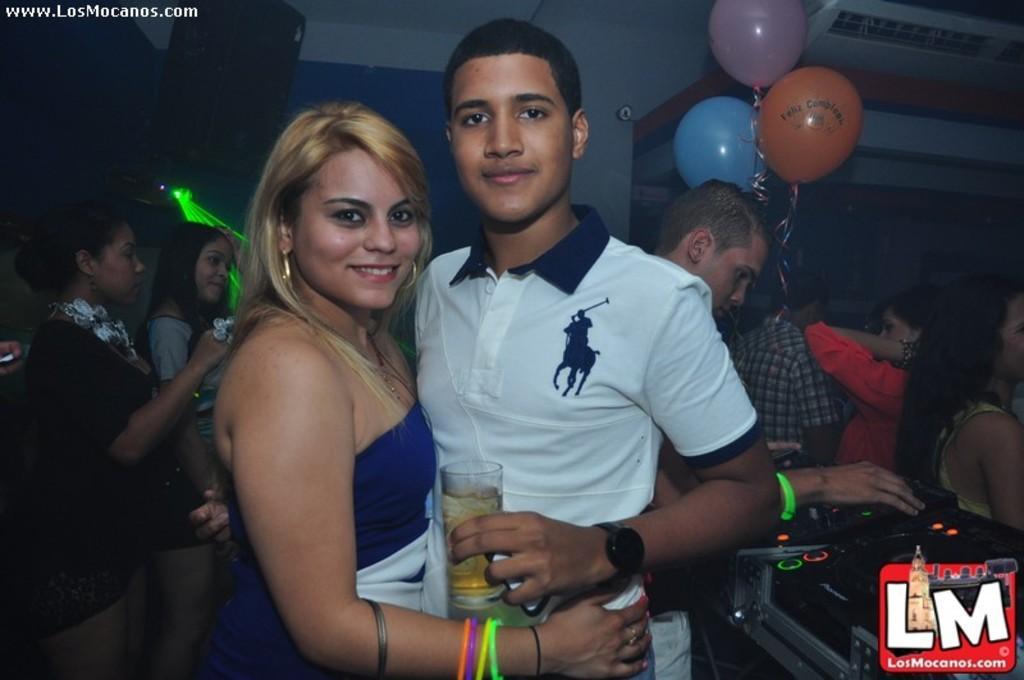In one or two sentences, can you explain what this image depicts? In the middle of the image two persons are standing, smiling and holding each other and he is holding a glass. Behind them few people are standing and he is playing some electronic devices. At the top of the image there is ceiling, on the ceiling there are some speakers and balloons. 